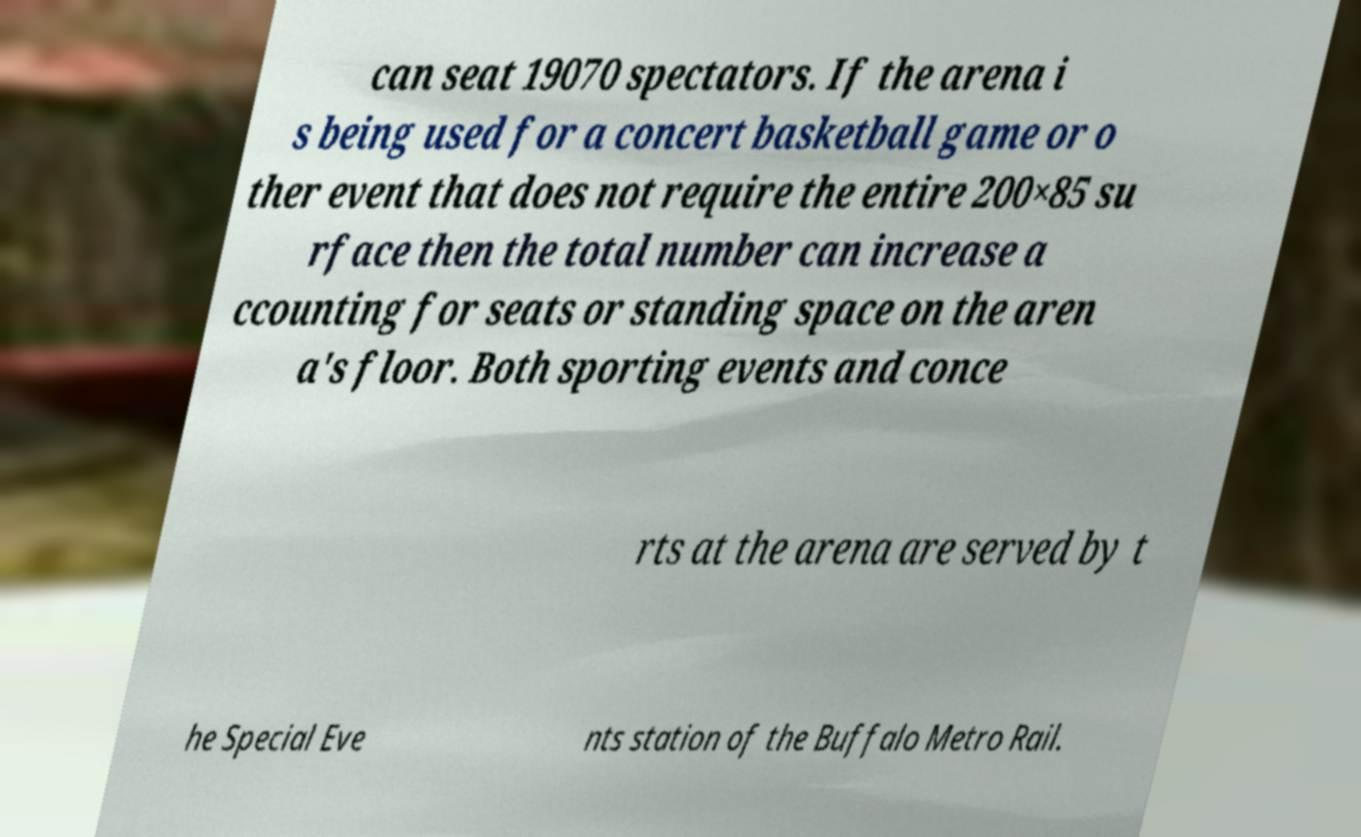For documentation purposes, I need the text within this image transcribed. Could you provide that? can seat 19070 spectators. If the arena i s being used for a concert basketball game or o ther event that does not require the entire 200×85 su rface then the total number can increase a ccounting for seats or standing space on the aren a's floor. Both sporting events and conce rts at the arena are served by t he Special Eve nts station of the Buffalo Metro Rail. 